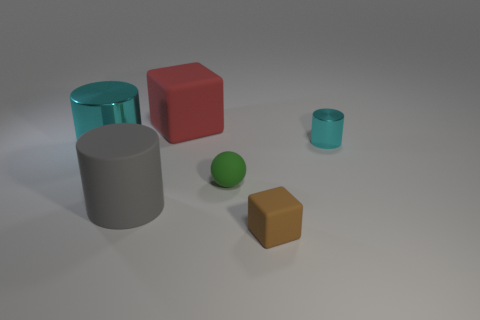Is the number of metal cylinders to the right of the red rubber thing greater than the number of gray metallic blocks?
Offer a very short reply. Yes. The rubber cube that is behind the metal cylinder that is to the left of the small cyan cylinder is what color?
Give a very brief answer. Red. What number of things are either rubber things in front of the large red rubber cube or gray rubber cylinders to the left of the green ball?
Offer a very short reply. 3. What is the color of the small cylinder?
Your answer should be compact. Cyan. What number of other cyan cylinders are made of the same material as the tiny cyan cylinder?
Your response must be concise. 1. Are there more small cyan shiny blocks than tiny cyan shiny things?
Your answer should be compact. No. There is a shiny cylinder to the left of the brown rubber thing; what number of cyan metal cylinders are on the right side of it?
Provide a succinct answer. 1. What number of objects are either small objects in front of the large cyan cylinder or cyan metal objects?
Provide a short and direct response. 4. Are there any big metallic objects of the same shape as the gray matte thing?
Your answer should be very brief. Yes. What is the shape of the metal thing that is on the left side of the block that is in front of the red block?
Offer a terse response. Cylinder. 